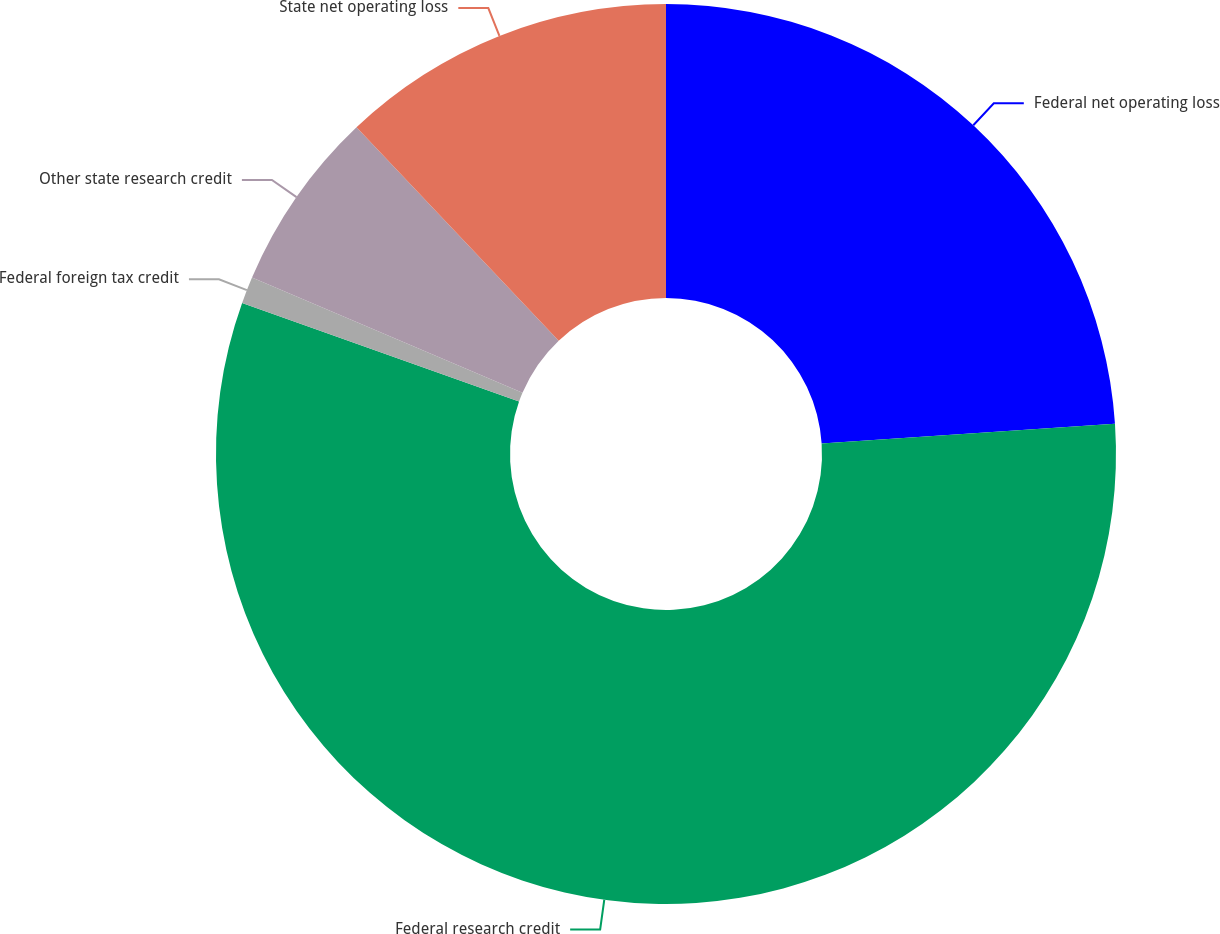Convert chart to OTSL. <chart><loc_0><loc_0><loc_500><loc_500><pie_chart><fcel>Federal net operating loss<fcel>Federal research credit<fcel>Federal foreign tax credit<fcel>Other state research credit<fcel>State net operating loss<nl><fcel>23.93%<fcel>56.52%<fcel>0.96%<fcel>6.52%<fcel>12.07%<nl></chart> 